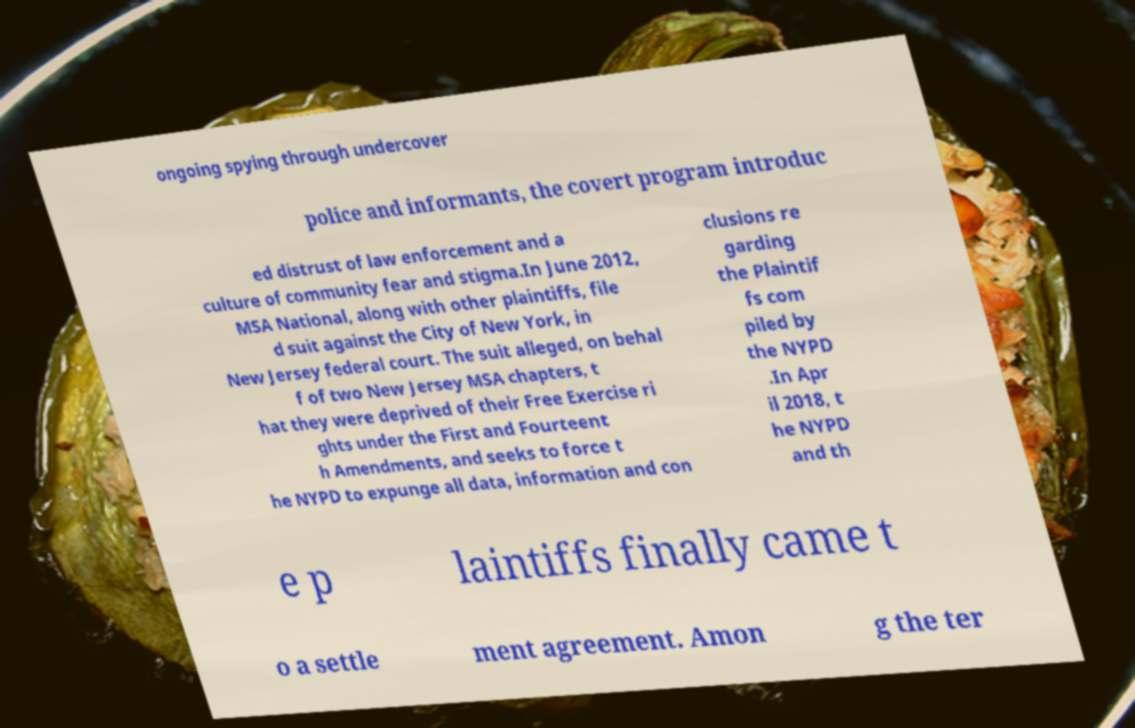There's text embedded in this image that I need extracted. Can you transcribe it verbatim? ongoing spying through undercover police and informants, the covert program introduc ed distrust of law enforcement and a culture of community fear and stigma.In June 2012, MSA National, along with other plaintiffs, file d suit against the City of New York, in New Jersey federal court. The suit alleged, on behal f of two New Jersey MSA chapters, t hat they were deprived of their Free Exercise ri ghts under the First and Fourteent h Amendments, and seeks to force t he NYPD to expunge all data, information and con clusions re garding the Plaintif fs com piled by the NYPD .In Apr il 2018, t he NYPD and th e p laintiffs finally came t o a settle ment agreement. Amon g the ter 